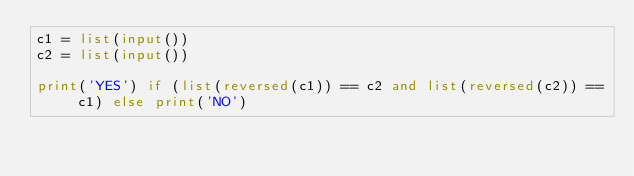<code> <loc_0><loc_0><loc_500><loc_500><_Python_>c1 = list(input())
c2 = list(input())

print('YES') if (list(reversed(c1)) == c2 and list(reversed(c2)) == c1) else print('NO')
</code> 